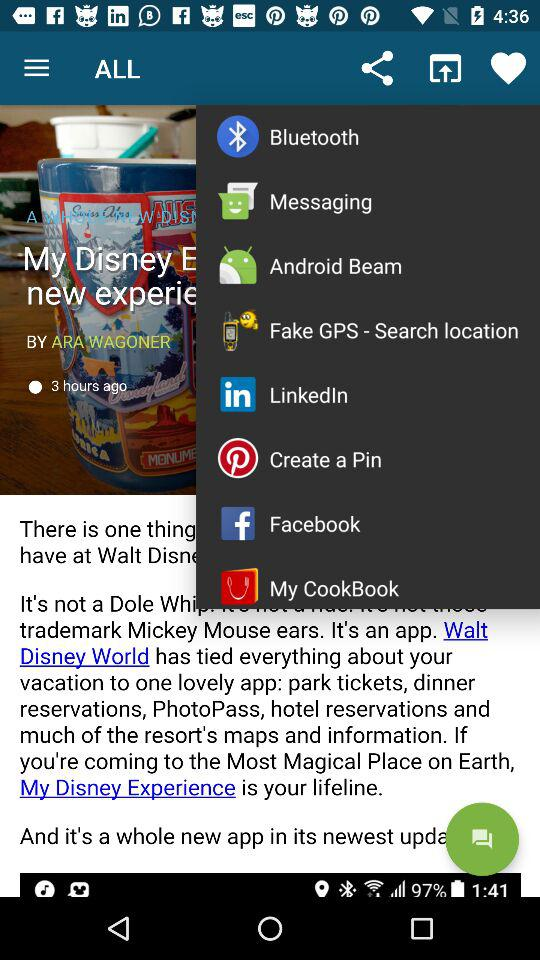When was the article published? The article was published 3 hours ago. 